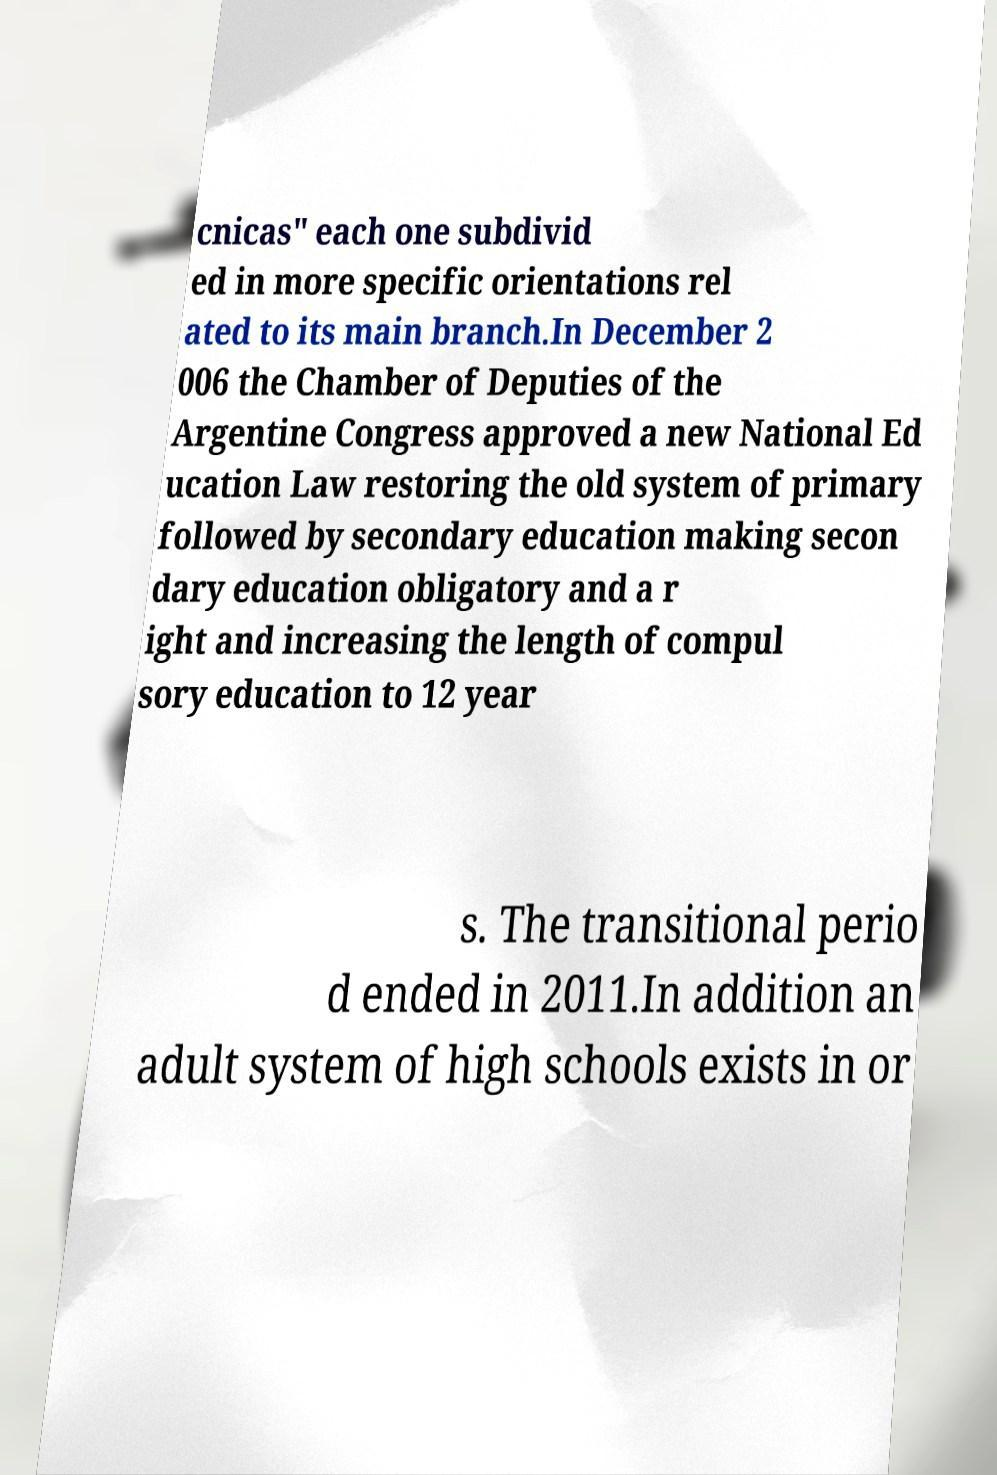There's text embedded in this image that I need extracted. Can you transcribe it verbatim? cnicas" each one subdivid ed in more specific orientations rel ated to its main branch.In December 2 006 the Chamber of Deputies of the Argentine Congress approved a new National Ed ucation Law restoring the old system of primary followed by secondary education making secon dary education obligatory and a r ight and increasing the length of compul sory education to 12 year s. The transitional perio d ended in 2011.In addition an adult system of high schools exists in or 